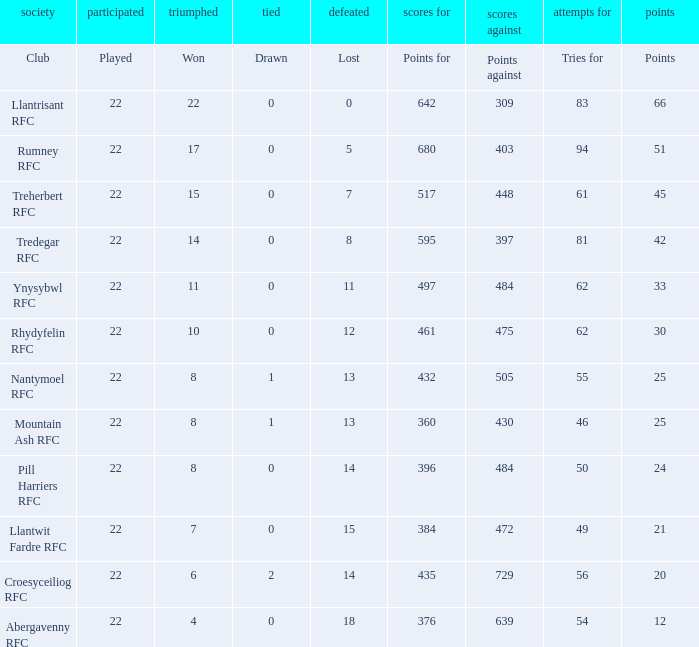How many attempts for were tallied by the team with precisely 396 points for? 50.0. 